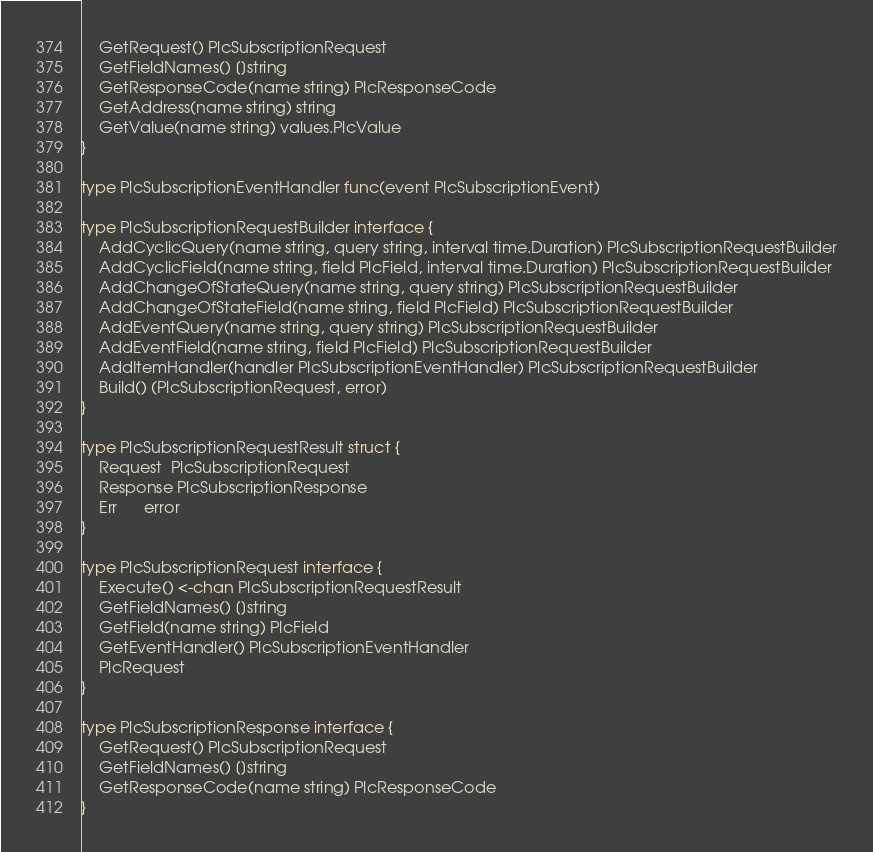Convert code to text. <code><loc_0><loc_0><loc_500><loc_500><_Go_>	GetRequest() PlcSubscriptionRequest
	GetFieldNames() []string
	GetResponseCode(name string) PlcResponseCode
	GetAddress(name string) string
	GetValue(name string) values.PlcValue
}

type PlcSubscriptionEventHandler func(event PlcSubscriptionEvent)

type PlcSubscriptionRequestBuilder interface {
	AddCyclicQuery(name string, query string, interval time.Duration) PlcSubscriptionRequestBuilder
	AddCyclicField(name string, field PlcField, interval time.Duration) PlcSubscriptionRequestBuilder
	AddChangeOfStateQuery(name string, query string) PlcSubscriptionRequestBuilder
	AddChangeOfStateField(name string, field PlcField) PlcSubscriptionRequestBuilder
	AddEventQuery(name string, query string) PlcSubscriptionRequestBuilder
	AddEventField(name string, field PlcField) PlcSubscriptionRequestBuilder
	AddItemHandler(handler PlcSubscriptionEventHandler) PlcSubscriptionRequestBuilder
	Build() (PlcSubscriptionRequest, error)
}

type PlcSubscriptionRequestResult struct {
	Request  PlcSubscriptionRequest
	Response PlcSubscriptionResponse
	Err      error
}

type PlcSubscriptionRequest interface {
	Execute() <-chan PlcSubscriptionRequestResult
	GetFieldNames() []string
	GetField(name string) PlcField
	GetEventHandler() PlcSubscriptionEventHandler
	PlcRequest
}

type PlcSubscriptionResponse interface {
	GetRequest() PlcSubscriptionRequest
	GetFieldNames() []string
	GetResponseCode(name string) PlcResponseCode
}
</code> 